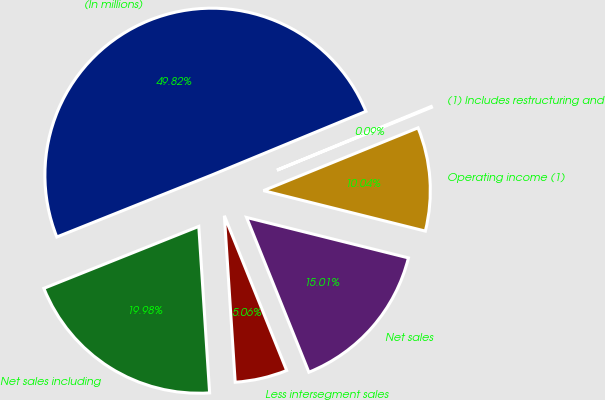Convert chart. <chart><loc_0><loc_0><loc_500><loc_500><pie_chart><fcel>(In millions)<fcel>Net sales including<fcel>Less intersegment sales<fcel>Net sales<fcel>Operating income (1)<fcel>(1) Includes restructuring and<nl><fcel>49.82%<fcel>19.98%<fcel>5.06%<fcel>15.01%<fcel>10.04%<fcel>0.09%<nl></chart> 